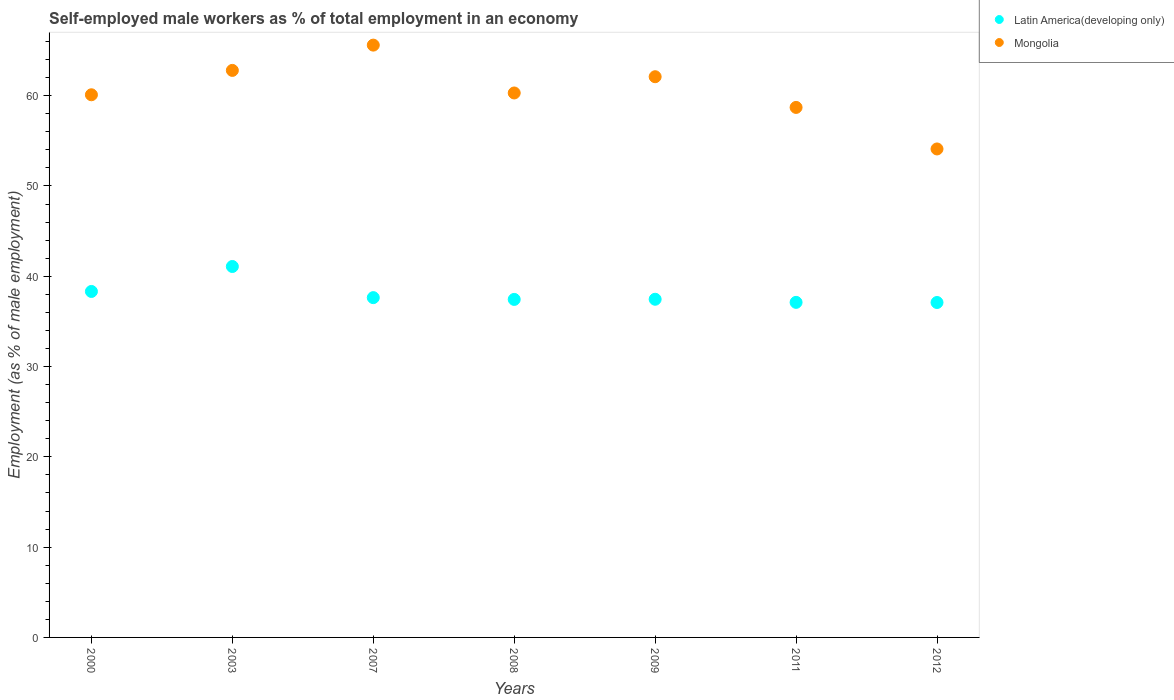How many different coloured dotlines are there?
Give a very brief answer. 2. Is the number of dotlines equal to the number of legend labels?
Keep it short and to the point. Yes. What is the percentage of self-employed male workers in Latin America(developing only) in 2000?
Offer a terse response. 38.32. Across all years, what is the maximum percentage of self-employed male workers in Latin America(developing only)?
Provide a succinct answer. 41.08. Across all years, what is the minimum percentage of self-employed male workers in Mongolia?
Ensure brevity in your answer.  54.1. What is the total percentage of self-employed male workers in Mongolia in the graph?
Offer a very short reply. 423.7. What is the difference between the percentage of self-employed male workers in Mongolia in 2007 and that in 2009?
Make the answer very short. 3.5. What is the difference between the percentage of self-employed male workers in Latin America(developing only) in 2011 and the percentage of self-employed male workers in Mongolia in 2012?
Your response must be concise. -16.99. What is the average percentage of self-employed male workers in Mongolia per year?
Keep it short and to the point. 60.53. In the year 2009, what is the difference between the percentage of self-employed male workers in Latin America(developing only) and percentage of self-employed male workers in Mongolia?
Provide a short and direct response. -24.65. What is the ratio of the percentage of self-employed male workers in Mongolia in 2009 to that in 2011?
Your response must be concise. 1.06. Is the percentage of self-employed male workers in Mongolia in 2000 less than that in 2009?
Your response must be concise. Yes. What is the difference between the highest and the second highest percentage of self-employed male workers in Latin America(developing only)?
Keep it short and to the point. 2.76. What is the difference between the highest and the lowest percentage of self-employed male workers in Mongolia?
Give a very brief answer. 11.5. Is the sum of the percentage of self-employed male workers in Mongolia in 2009 and 2012 greater than the maximum percentage of self-employed male workers in Latin America(developing only) across all years?
Make the answer very short. Yes. Does the percentage of self-employed male workers in Latin America(developing only) monotonically increase over the years?
Your answer should be compact. No. How many dotlines are there?
Your answer should be very brief. 2. Does the graph contain any zero values?
Your answer should be compact. No. How many legend labels are there?
Offer a terse response. 2. What is the title of the graph?
Make the answer very short. Self-employed male workers as % of total employment in an economy. Does "Guinea" appear as one of the legend labels in the graph?
Your answer should be compact. No. What is the label or title of the X-axis?
Your response must be concise. Years. What is the label or title of the Y-axis?
Make the answer very short. Employment (as % of male employment). What is the Employment (as % of male employment) in Latin America(developing only) in 2000?
Your response must be concise. 38.32. What is the Employment (as % of male employment) of Mongolia in 2000?
Offer a very short reply. 60.1. What is the Employment (as % of male employment) in Latin America(developing only) in 2003?
Your answer should be very brief. 41.08. What is the Employment (as % of male employment) in Mongolia in 2003?
Provide a succinct answer. 62.8. What is the Employment (as % of male employment) of Latin America(developing only) in 2007?
Offer a very short reply. 37.63. What is the Employment (as % of male employment) of Mongolia in 2007?
Make the answer very short. 65.6. What is the Employment (as % of male employment) of Latin America(developing only) in 2008?
Your answer should be very brief. 37.44. What is the Employment (as % of male employment) in Mongolia in 2008?
Your answer should be very brief. 60.3. What is the Employment (as % of male employment) in Latin America(developing only) in 2009?
Ensure brevity in your answer.  37.45. What is the Employment (as % of male employment) in Mongolia in 2009?
Your response must be concise. 62.1. What is the Employment (as % of male employment) in Latin America(developing only) in 2011?
Your response must be concise. 37.11. What is the Employment (as % of male employment) in Mongolia in 2011?
Your answer should be very brief. 58.7. What is the Employment (as % of male employment) of Latin America(developing only) in 2012?
Ensure brevity in your answer.  37.09. What is the Employment (as % of male employment) in Mongolia in 2012?
Your answer should be very brief. 54.1. Across all years, what is the maximum Employment (as % of male employment) in Latin America(developing only)?
Your answer should be compact. 41.08. Across all years, what is the maximum Employment (as % of male employment) in Mongolia?
Ensure brevity in your answer.  65.6. Across all years, what is the minimum Employment (as % of male employment) of Latin America(developing only)?
Make the answer very short. 37.09. Across all years, what is the minimum Employment (as % of male employment) in Mongolia?
Your answer should be compact. 54.1. What is the total Employment (as % of male employment) of Latin America(developing only) in the graph?
Provide a succinct answer. 266.13. What is the total Employment (as % of male employment) in Mongolia in the graph?
Ensure brevity in your answer.  423.7. What is the difference between the Employment (as % of male employment) of Latin America(developing only) in 2000 and that in 2003?
Provide a short and direct response. -2.76. What is the difference between the Employment (as % of male employment) in Latin America(developing only) in 2000 and that in 2007?
Your answer should be compact. 0.68. What is the difference between the Employment (as % of male employment) of Mongolia in 2000 and that in 2007?
Your response must be concise. -5.5. What is the difference between the Employment (as % of male employment) in Latin America(developing only) in 2000 and that in 2008?
Give a very brief answer. 0.88. What is the difference between the Employment (as % of male employment) of Latin America(developing only) in 2000 and that in 2009?
Offer a terse response. 0.86. What is the difference between the Employment (as % of male employment) in Latin America(developing only) in 2000 and that in 2011?
Provide a succinct answer. 1.21. What is the difference between the Employment (as % of male employment) of Mongolia in 2000 and that in 2011?
Provide a succinct answer. 1.4. What is the difference between the Employment (as % of male employment) of Latin America(developing only) in 2000 and that in 2012?
Keep it short and to the point. 1.22. What is the difference between the Employment (as % of male employment) in Mongolia in 2000 and that in 2012?
Provide a short and direct response. 6. What is the difference between the Employment (as % of male employment) in Latin America(developing only) in 2003 and that in 2007?
Your answer should be very brief. 3.45. What is the difference between the Employment (as % of male employment) in Mongolia in 2003 and that in 2007?
Offer a very short reply. -2.8. What is the difference between the Employment (as % of male employment) of Latin America(developing only) in 2003 and that in 2008?
Ensure brevity in your answer.  3.65. What is the difference between the Employment (as % of male employment) in Mongolia in 2003 and that in 2008?
Ensure brevity in your answer.  2.5. What is the difference between the Employment (as % of male employment) of Latin America(developing only) in 2003 and that in 2009?
Your answer should be very brief. 3.63. What is the difference between the Employment (as % of male employment) in Latin America(developing only) in 2003 and that in 2011?
Your response must be concise. 3.97. What is the difference between the Employment (as % of male employment) in Latin America(developing only) in 2003 and that in 2012?
Your answer should be compact. 3.99. What is the difference between the Employment (as % of male employment) in Latin America(developing only) in 2007 and that in 2008?
Keep it short and to the point. 0.2. What is the difference between the Employment (as % of male employment) in Latin America(developing only) in 2007 and that in 2009?
Offer a terse response. 0.18. What is the difference between the Employment (as % of male employment) in Latin America(developing only) in 2007 and that in 2011?
Provide a succinct answer. 0.52. What is the difference between the Employment (as % of male employment) in Latin America(developing only) in 2007 and that in 2012?
Offer a terse response. 0.54. What is the difference between the Employment (as % of male employment) in Latin America(developing only) in 2008 and that in 2009?
Provide a short and direct response. -0.02. What is the difference between the Employment (as % of male employment) of Mongolia in 2008 and that in 2009?
Provide a short and direct response. -1.8. What is the difference between the Employment (as % of male employment) of Latin America(developing only) in 2008 and that in 2011?
Your response must be concise. 0.33. What is the difference between the Employment (as % of male employment) of Latin America(developing only) in 2008 and that in 2012?
Provide a succinct answer. 0.34. What is the difference between the Employment (as % of male employment) in Mongolia in 2008 and that in 2012?
Offer a very short reply. 6.2. What is the difference between the Employment (as % of male employment) of Latin America(developing only) in 2009 and that in 2011?
Your answer should be very brief. 0.34. What is the difference between the Employment (as % of male employment) of Latin America(developing only) in 2009 and that in 2012?
Keep it short and to the point. 0.36. What is the difference between the Employment (as % of male employment) in Mongolia in 2009 and that in 2012?
Your answer should be compact. 8. What is the difference between the Employment (as % of male employment) of Latin America(developing only) in 2011 and that in 2012?
Provide a short and direct response. 0.01. What is the difference between the Employment (as % of male employment) of Latin America(developing only) in 2000 and the Employment (as % of male employment) of Mongolia in 2003?
Give a very brief answer. -24.48. What is the difference between the Employment (as % of male employment) in Latin America(developing only) in 2000 and the Employment (as % of male employment) in Mongolia in 2007?
Offer a terse response. -27.28. What is the difference between the Employment (as % of male employment) of Latin America(developing only) in 2000 and the Employment (as % of male employment) of Mongolia in 2008?
Give a very brief answer. -21.98. What is the difference between the Employment (as % of male employment) of Latin America(developing only) in 2000 and the Employment (as % of male employment) of Mongolia in 2009?
Ensure brevity in your answer.  -23.78. What is the difference between the Employment (as % of male employment) in Latin America(developing only) in 2000 and the Employment (as % of male employment) in Mongolia in 2011?
Ensure brevity in your answer.  -20.38. What is the difference between the Employment (as % of male employment) of Latin America(developing only) in 2000 and the Employment (as % of male employment) of Mongolia in 2012?
Your answer should be compact. -15.78. What is the difference between the Employment (as % of male employment) in Latin America(developing only) in 2003 and the Employment (as % of male employment) in Mongolia in 2007?
Ensure brevity in your answer.  -24.52. What is the difference between the Employment (as % of male employment) of Latin America(developing only) in 2003 and the Employment (as % of male employment) of Mongolia in 2008?
Offer a very short reply. -19.22. What is the difference between the Employment (as % of male employment) in Latin America(developing only) in 2003 and the Employment (as % of male employment) in Mongolia in 2009?
Make the answer very short. -21.02. What is the difference between the Employment (as % of male employment) in Latin America(developing only) in 2003 and the Employment (as % of male employment) in Mongolia in 2011?
Your response must be concise. -17.62. What is the difference between the Employment (as % of male employment) in Latin America(developing only) in 2003 and the Employment (as % of male employment) in Mongolia in 2012?
Your answer should be compact. -13.02. What is the difference between the Employment (as % of male employment) in Latin America(developing only) in 2007 and the Employment (as % of male employment) in Mongolia in 2008?
Provide a short and direct response. -22.67. What is the difference between the Employment (as % of male employment) in Latin America(developing only) in 2007 and the Employment (as % of male employment) in Mongolia in 2009?
Provide a succinct answer. -24.47. What is the difference between the Employment (as % of male employment) in Latin America(developing only) in 2007 and the Employment (as % of male employment) in Mongolia in 2011?
Your answer should be compact. -21.07. What is the difference between the Employment (as % of male employment) of Latin America(developing only) in 2007 and the Employment (as % of male employment) of Mongolia in 2012?
Offer a very short reply. -16.47. What is the difference between the Employment (as % of male employment) in Latin America(developing only) in 2008 and the Employment (as % of male employment) in Mongolia in 2009?
Your answer should be compact. -24.66. What is the difference between the Employment (as % of male employment) of Latin America(developing only) in 2008 and the Employment (as % of male employment) of Mongolia in 2011?
Your answer should be very brief. -21.26. What is the difference between the Employment (as % of male employment) of Latin America(developing only) in 2008 and the Employment (as % of male employment) of Mongolia in 2012?
Ensure brevity in your answer.  -16.66. What is the difference between the Employment (as % of male employment) of Latin America(developing only) in 2009 and the Employment (as % of male employment) of Mongolia in 2011?
Make the answer very short. -21.25. What is the difference between the Employment (as % of male employment) of Latin America(developing only) in 2009 and the Employment (as % of male employment) of Mongolia in 2012?
Ensure brevity in your answer.  -16.65. What is the difference between the Employment (as % of male employment) in Latin America(developing only) in 2011 and the Employment (as % of male employment) in Mongolia in 2012?
Keep it short and to the point. -16.99. What is the average Employment (as % of male employment) in Latin America(developing only) per year?
Provide a short and direct response. 38.02. What is the average Employment (as % of male employment) of Mongolia per year?
Give a very brief answer. 60.53. In the year 2000, what is the difference between the Employment (as % of male employment) in Latin America(developing only) and Employment (as % of male employment) in Mongolia?
Your answer should be compact. -21.78. In the year 2003, what is the difference between the Employment (as % of male employment) of Latin America(developing only) and Employment (as % of male employment) of Mongolia?
Provide a short and direct response. -21.72. In the year 2007, what is the difference between the Employment (as % of male employment) in Latin America(developing only) and Employment (as % of male employment) in Mongolia?
Provide a succinct answer. -27.97. In the year 2008, what is the difference between the Employment (as % of male employment) of Latin America(developing only) and Employment (as % of male employment) of Mongolia?
Make the answer very short. -22.86. In the year 2009, what is the difference between the Employment (as % of male employment) in Latin America(developing only) and Employment (as % of male employment) in Mongolia?
Offer a very short reply. -24.65. In the year 2011, what is the difference between the Employment (as % of male employment) in Latin America(developing only) and Employment (as % of male employment) in Mongolia?
Keep it short and to the point. -21.59. In the year 2012, what is the difference between the Employment (as % of male employment) of Latin America(developing only) and Employment (as % of male employment) of Mongolia?
Offer a terse response. -17.01. What is the ratio of the Employment (as % of male employment) of Latin America(developing only) in 2000 to that in 2003?
Offer a very short reply. 0.93. What is the ratio of the Employment (as % of male employment) in Latin America(developing only) in 2000 to that in 2007?
Provide a succinct answer. 1.02. What is the ratio of the Employment (as % of male employment) in Mongolia in 2000 to that in 2007?
Offer a terse response. 0.92. What is the ratio of the Employment (as % of male employment) in Latin America(developing only) in 2000 to that in 2008?
Your answer should be compact. 1.02. What is the ratio of the Employment (as % of male employment) in Latin America(developing only) in 2000 to that in 2009?
Give a very brief answer. 1.02. What is the ratio of the Employment (as % of male employment) of Mongolia in 2000 to that in 2009?
Make the answer very short. 0.97. What is the ratio of the Employment (as % of male employment) in Latin America(developing only) in 2000 to that in 2011?
Provide a succinct answer. 1.03. What is the ratio of the Employment (as % of male employment) in Mongolia in 2000 to that in 2011?
Your answer should be compact. 1.02. What is the ratio of the Employment (as % of male employment) in Latin America(developing only) in 2000 to that in 2012?
Offer a very short reply. 1.03. What is the ratio of the Employment (as % of male employment) in Mongolia in 2000 to that in 2012?
Give a very brief answer. 1.11. What is the ratio of the Employment (as % of male employment) in Latin America(developing only) in 2003 to that in 2007?
Your answer should be compact. 1.09. What is the ratio of the Employment (as % of male employment) in Mongolia in 2003 to that in 2007?
Provide a short and direct response. 0.96. What is the ratio of the Employment (as % of male employment) of Latin America(developing only) in 2003 to that in 2008?
Ensure brevity in your answer.  1.1. What is the ratio of the Employment (as % of male employment) in Mongolia in 2003 to that in 2008?
Offer a terse response. 1.04. What is the ratio of the Employment (as % of male employment) of Latin America(developing only) in 2003 to that in 2009?
Provide a succinct answer. 1.1. What is the ratio of the Employment (as % of male employment) of Mongolia in 2003 to that in 2009?
Your response must be concise. 1.01. What is the ratio of the Employment (as % of male employment) of Latin America(developing only) in 2003 to that in 2011?
Give a very brief answer. 1.11. What is the ratio of the Employment (as % of male employment) in Mongolia in 2003 to that in 2011?
Offer a very short reply. 1.07. What is the ratio of the Employment (as % of male employment) in Latin America(developing only) in 2003 to that in 2012?
Your answer should be very brief. 1.11. What is the ratio of the Employment (as % of male employment) of Mongolia in 2003 to that in 2012?
Make the answer very short. 1.16. What is the ratio of the Employment (as % of male employment) in Mongolia in 2007 to that in 2008?
Provide a succinct answer. 1.09. What is the ratio of the Employment (as % of male employment) of Mongolia in 2007 to that in 2009?
Provide a succinct answer. 1.06. What is the ratio of the Employment (as % of male employment) in Latin America(developing only) in 2007 to that in 2011?
Your answer should be very brief. 1.01. What is the ratio of the Employment (as % of male employment) in Mongolia in 2007 to that in 2011?
Give a very brief answer. 1.12. What is the ratio of the Employment (as % of male employment) of Latin America(developing only) in 2007 to that in 2012?
Provide a short and direct response. 1.01. What is the ratio of the Employment (as % of male employment) of Mongolia in 2007 to that in 2012?
Provide a succinct answer. 1.21. What is the ratio of the Employment (as % of male employment) of Latin America(developing only) in 2008 to that in 2009?
Offer a terse response. 1. What is the ratio of the Employment (as % of male employment) in Latin America(developing only) in 2008 to that in 2011?
Your answer should be compact. 1.01. What is the ratio of the Employment (as % of male employment) of Mongolia in 2008 to that in 2011?
Make the answer very short. 1.03. What is the ratio of the Employment (as % of male employment) of Latin America(developing only) in 2008 to that in 2012?
Provide a short and direct response. 1.01. What is the ratio of the Employment (as % of male employment) of Mongolia in 2008 to that in 2012?
Make the answer very short. 1.11. What is the ratio of the Employment (as % of male employment) of Latin America(developing only) in 2009 to that in 2011?
Make the answer very short. 1.01. What is the ratio of the Employment (as % of male employment) in Mongolia in 2009 to that in 2011?
Your answer should be compact. 1.06. What is the ratio of the Employment (as % of male employment) of Latin America(developing only) in 2009 to that in 2012?
Offer a very short reply. 1.01. What is the ratio of the Employment (as % of male employment) of Mongolia in 2009 to that in 2012?
Offer a very short reply. 1.15. What is the ratio of the Employment (as % of male employment) of Mongolia in 2011 to that in 2012?
Ensure brevity in your answer.  1.08. What is the difference between the highest and the second highest Employment (as % of male employment) of Latin America(developing only)?
Offer a very short reply. 2.76. What is the difference between the highest and the second highest Employment (as % of male employment) of Mongolia?
Make the answer very short. 2.8. What is the difference between the highest and the lowest Employment (as % of male employment) in Latin America(developing only)?
Offer a very short reply. 3.99. What is the difference between the highest and the lowest Employment (as % of male employment) in Mongolia?
Give a very brief answer. 11.5. 